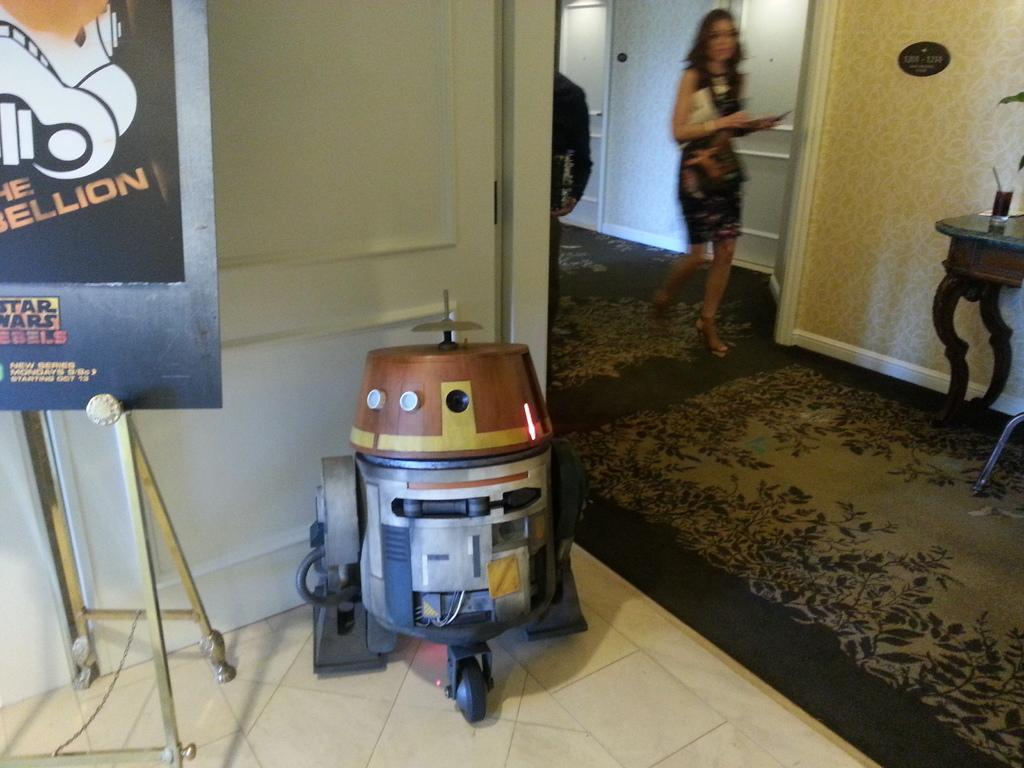<image>
Give a short and clear explanation of the subsequent image. R2D2 stands next to a sign with Star Wars on it. 